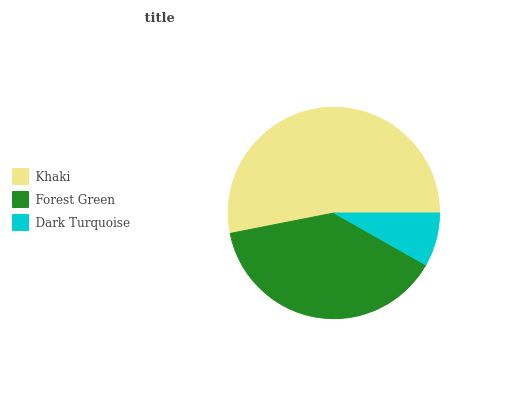Is Dark Turquoise the minimum?
Answer yes or no. Yes. Is Khaki the maximum?
Answer yes or no. Yes. Is Forest Green the minimum?
Answer yes or no. No. Is Forest Green the maximum?
Answer yes or no. No. Is Khaki greater than Forest Green?
Answer yes or no. Yes. Is Forest Green less than Khaki?
Answer yes or no. Yes. Is Forest Green greater than Khaki?
Answer yes or no. No. Is Khaki less than Forest Green?
Answer yes or no. No. Is Forest Green the high median?
Answer yes or no. Yes. Is Forest Green the low median?
Answer yes or no. Yes. Is Khaki the high median?
Answer yes or no. No. Is Khaki the low median?
Answer yes or no. No. 